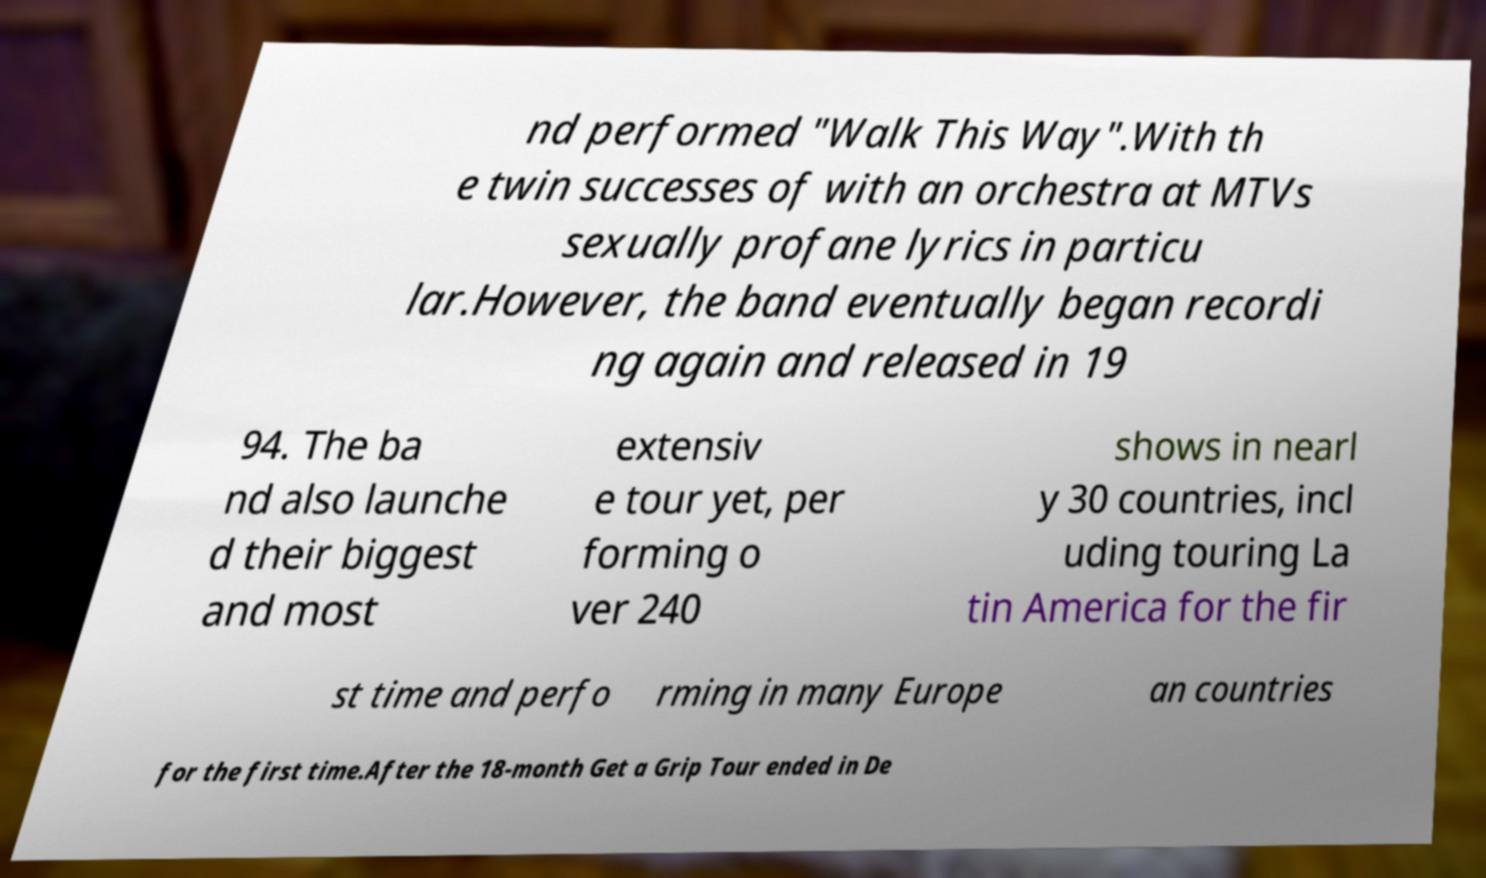For documentation purposes, I need the text within this image transcribed. Could you provide that? nd performed "Walk This Way".With th e twin successes of with an orchestra at MTVs sexually profane lyrics in particu lar.However, the band eventually began recordi ng again and released in 19 94. The ba nd also launche d their biggest and most extensiv e tour yet, per forming o ver 240 shows in nearl y 30 countries, incl uding touring La tin America for the fir st time and perfo rming in many Europe an countries for the first time.After the 18-month Get a Grip Tour ended in De 